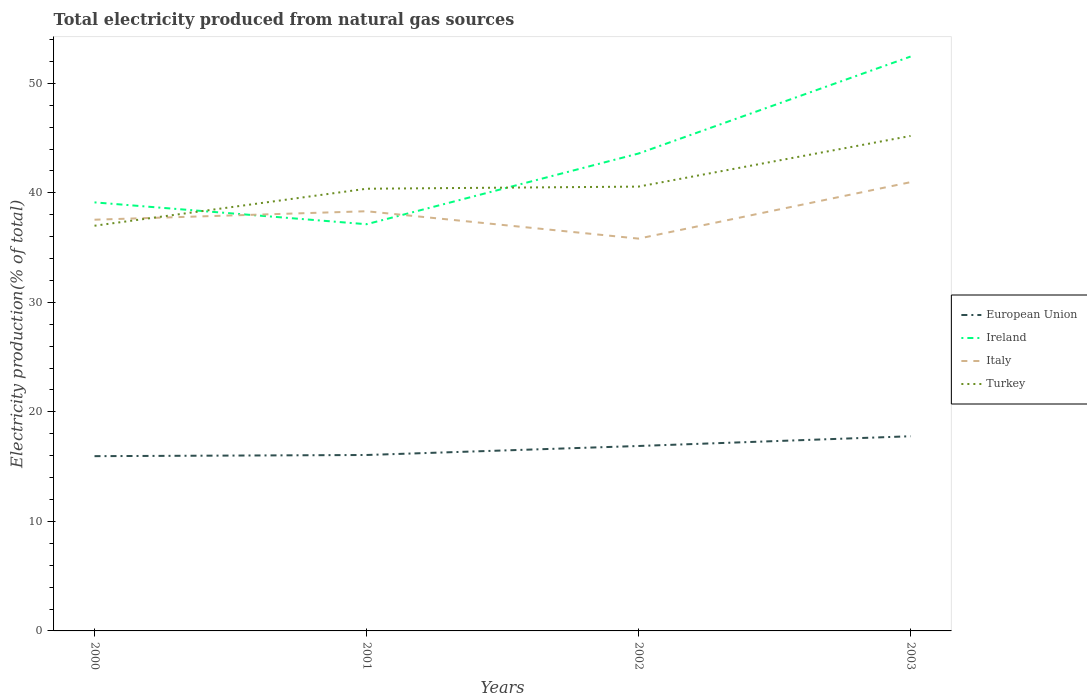How many different coloured lines are there?
Provide a short and direct response. 4. Across all years, what is the maximum total electricity produced in Ireland?
Provide a short and direct response. 37.13. What is the total total electricity produced in European Union in the graph?
Make the answer very short. -0.11. What is the difference between the highest and the second highest total electricity produced in Ireland?
Your answer should be very brief. 15.31. What is the difference between the highest and the lowest total electricity produced in Ireland?
Give a very brief answer. 2. Is the total electricity produced in European Union strictly greater than the total electricity produced in Ireland over the years?
Provide a short and direct response. Yes. What is the difference between two consecutive major ticks on the Y-axis?
Offer a terse response. 10. Does the graph contain any zero values?
Your answer should be very brief. No. How many legend labels are there?
Your answer should be compact. 4. What is the title of the graph?
Provide a succinct answer. Total electricity produced from natural gas sources. What is the label or title of the X-axis?
Your response must be concise. Years. What is the Electricity production(% of total) in European Union in 2000?
Your response must be concise. 15.96. What is the Electricity production(% of total) in Ireland in 2000?
Keep it short and to the point. 39.13. What is the Electricity production(% of total) in Italy in 2000?
Ensure brevity in your answer.  37.55. What is the Electricity production(% of total) in Turkey in 2000?
Your answer should be very brief. 37. What is the Electricity production(% of total) in European Union in 2001?
Keep it short and to the point. 16.06. What is the Electricity production(% of total) in Ireland in 2001?
Keep it short and to the point. 37.13. What is the Electricity production(% of total) in Italy in 2001?
Make the answer very short. 38.32. What is the Electricity production(% of total) of Turkey in 2001?
Ensure brevity in your answer.  40.37. What is the Electricity production(% of total) in European Union in 2002?
Offer a very short reply. 16.89. What is the Electricity production(% of total) of Ireland in 2002?
Offer a very short reply. 43.59. What is the Electricity production(% of total) in Italy in 2002?
Your answer should be very brief. 35.82. What is the Electricity production(% of total) of Turkey in 2002?
Your answer should be compact. 40.57. What is the Electricity production(% of total) of European Union in 2003?
Your answer should be very brief. 17.78. What is the Electricity production(% of total) of Ireland in 2003?
Your answer should be very brief. 52.44. What is the Electricity production(% of total) in Italy in 2003?
Provide a short and direct response. 40.97. What is the Electricity production(% of total) in Turkey in 2003?
Ensure brevity in your answer.  45.2. Across all years, what is the maximum Electricity production(% of total) in European Union?
Give a very brief answer. 17.78. Across all years, what is the maximum Electricity production(% of total) in Ireland?
Offer a terse response. 52.44. Across all years, what is the maximum Electricity production(% of total) of Italy?
Your response must be concise. 40.97. Across all years, what is the maximum Electricity production(% of total) in Turkey?
Provide a succinct answer. 45.2. Across all years, what is the minimum Electricity production(% of total) in European Union?
Keep it short and to the point. 15.96. Across all years, what is the minimum Electricity production(% of total) of Ireland?
Provide a short and direct response. 37.13. Across all years, what is the minimum Electricity production(% of total) in Italy?
Offer a very short reply. 35.82. Across all years, what is the minimum Electricity production(% of total) in Turkey?
Your answer should be very brief. 37. What is the total Electricity production(% of total) of European Union in the graph?
Your answer should be compact. 66.68. What is the total Electricity production(% of total) in Ireland in the graph?
Offer a very short reply. 172.3. What is the total Electricity production(% of total) of Italy in the graph?
Offer a very short reply. 152.66. What is the total Electricity production(% of total) in Turkey in the graph?
Offer a very short reply. 163.14. What is the difference between the Electricity production(% of total) in European Union in 2000 and that in 2001?
Offer a very short reply. -0.11. What is the difference between the Electricity production(% of total) in Ireland in 2000 and that in 2001?
Give a very brief answer. 1.99. What is the difference between the Electricity production(% of total) in Italy in 2000 and that in 2001?
Keep it short and to the point. -0.77. What is the difference between the Electricity production(% of total) of Turkey in 2000 and that in 2001?
Give a very brief answer. -3.38. What is the difference between the Electricity production(% of total) in European Union in 2000 and that in 2002?
Ensure brevity in your answer.  -0.93. What is the difference between the Electricity production(% of total) of Ireland in 2000 and that in 2002?
Provide a short and direct response. -4.46. What is the difference between the Electricity production(% of total) in Italy in 2000 and that in 2002?
Keep it short and to the point. 1.73. What is the difference between the Electricity production(% of total) in Turkey in 2000 and that in 2002?
Keep it short and to the point. -3.57. What is the difference between the Electricity production(% of total) in European Union in 2000 and that in 2003?
Provide a short and direct response. -1.82. What is the difference between the Electricity production(% of total) of Ireland in 2000 and that in 2003?
Your answer should be compact. -13.31. What is the difference between the Electricity production(% of total) in Italy in 2000 and that in 2003?
Your answer should be compact. -3.43. What is the difference between the Electricity production(% of total) of Turkey in 2000 and that in 2003?
Provide a succinct answer. -8.2. What is the difference between the Electricity production(% of total) in European Union in 2001 and that in 2002?
Provide a succinct answer. -0.82. What is the difference between the Electricity production(% of total) in Ireland in 2001 and that in 2002?
Your answer should be very brief. -6.46. What is the difference between the Electricity production(% of total) in Italy in 2001 and that in 2002?
Give a very brief answer. 2.5. What is the difference between the Electricity production(% of total) in Turkey in 2001 and that in 2002?
Keep it short and to the point. -0.19. What is the difference between the Electricity production(% of total) of European Union in 2001 and that in 2003?
Ensure brevity in your answer.  -1.71. What is the difference between the Electricity production(% of total) of Ireland in 2001 and that in 2003?
Give a very brief answer. -15.31. What is the difference between the Electricity production(% of total) in Italy in 2001 and that in 2003?
Provide a short and direct response. -2.65. What is the difference between the Electricity production(% of total) of Turkey in 2001 and that in 2003?
Your answer should be very brief. -4.82. What is the difference between the Electricity production(% of total) of European Union in 2002 and that in 2003?
Your answer should be compact. -0.89. What is the difference between the Electricity production(% of total) of Ireland in 2002 and that in 2003?
Provide a succinct answer. -8.85. What is the difference between the Electricity production(% of total) of Italy in 2002 and that in 2003?
Your response must be concise. -5.15. What is the difference between the Electricity production(% of total) in Turkey in 2002 and that in 2003?
Offer a very short reply. -4.63. What is the difference between the Electricity production(% of total) in European Union in 2000 and the Electricity production(% of total) in Ireland in 2001?
Your answer should be compact. -21.18. What is the difference between the Electricity production(% of total) of European Union in 2000 and the Electricity production(% of total) of Italy in 2001?
Make the answer very short. -22.36. What is the difference between the Electricity production(% of total) in European Union in 2000 and the Electricity production(% of total) in Turkey in 2001?
Give a very brief answer. -24.42. What is the difference between the Electricity production(% of total) of Ireland in 2000 and the Electricity production(% of total) of Italy in 2001?
Make the answer very short. 0.81. What is the difference between the Electricity production(% of total) of Ireland in 2000 and the Electricity production(% of total) of Turkey in 2001?
Your answer should be very brief. -1.25. What is the difference between the Electricity production(% of total) of Italy in 2000 and the Electricity production(% of total) of Turkey in 2001?
Your answer should be compact. -2.83. What is the difference between the Electricity production(% of total) of European Union in 2000 and the Electricity production(% of total) of Ireland in 2002?
Offer a terse response. -27.63. What is the difference between the Electricity production(% of total) of European Union in 2000 and the Electricity production(% of total) of Italy in 2002?
Offer a very short reply. -19.86. What is the difference between the Electricity production(% of total) of European Union in 2000 and the Electricity production(% of total) of Turkey in 2002?
Provide a short and direct response. -24.61. What is the difference between the Electricity production(% of total) of Ireland in 2000 and the Electricity production(% of total) of Italy in 2002?
Keep it short and to the point. 3.31. What is the difference between the Electricity production(% of total) in Ireland in 2000 and the Electricity production(% of total) in Turkey in 2002?
Provide a short and direct response. -1.44. What is the difference between the Electricity production(% of total) in Italy in 2000 and the Electricity production(% of total) in Turkey in 2002?
Provide a succinct answer. -3.02. What is the difference between the Electricity production(% of total) in European Union in 2000 and the Electricity production(% of total) in Ireland in 2003?
Offer a terse response. -36.49. What is the difference between the Electricity production(% of total) in European Union in 2000 and the Electricity production(% of total) in Italy in 2003?
Offer a very short reply. -25.02. What is the difference between the Electricity production(% of total) in European Union in 2000 and the Electricity production(% of total) in Turkey in 2003?
Give a very brief answer. -29.24. What is the difference between the Electricity production(% of total) in Ireland in 2000 and the Electricity production(% of total) in Italy in 2003?
Provide a succinct answer. -1.85. What is the difference between the Electricity production(% of total) in Ireland in 2000 and the Electricity production(% of total) in Turkey in 2003?
Your response must be concise. -6.07. What is the difference between the Electricity production(% of total) of Italy in 2000 and the Electricity production(% of total) of Turkey in 2003?
Make the answer very short. -7.65. What is the difference between the Electricity production(% of total) in European Union in 2001 and the Electricity production(% of total) in Ireland in 2002?
Offer a very short reply. -27.53. What is the difference between the Electricity production(% of total) of European Union in 2001 and the Electricity production(% of total) of Italy in 2002?
Make the answer very short. -19.76. What is the difference between the Electricity production(% of total) of European Union in 2001 and the Electricity production(% of total) of Turkey in 2002?
Offer a very short reply. -24.51. What is the difference between the Electricity production(% of total) in Ireland in 2001 and the Electricity production(% of total) in Italy in 2002?
Make the answer very short. 1.31. What is the difference between the Electricity production(% of total) of Ireland in 2001 and the Electricity production(% of total) of Turkey in 2002?
Your answer should be very brief. -3.43. What is the difference between the Electricity production(% of total) in Italy in 2001 and the Electricity production(% of total) in Turkey in 2002?
Make the answer very short. -2.25. What is the difference between the Electricity production(% of total) of European Union in 2001 and the Electricity production(% of total) of Ireland in 2003?
Your response must be concise. -36.38. What is the difference between the Electricity production(% of total) of European Union in 2001 and the Electricity production(% of total) of Italy in 2003?
Offer a very short reply. -24.91. What is the difference between the Electricity production(% of total) of European Union in 2001 and the Electricity production(% of total) of Turkey in 2003?
Give a very brief answer. -29.13. What is the difference between the Electricity production(% of total) of Ireland in 2001 and the Electricity production(% of total) of Italy in 2003?
Give a very brief answer. -3.84. What is the difference between the Electricity production(% of total) of Ireland in 2001 and the Electricity production(% of total) of Turkey in 2003?
Offer a terse response. -8.06. What is the difference between the Electricity production(% of total) in Italy in 2001 and the Electricity production(% of total) in Turkey in 2003?
Provide a short and direct response. -6.88. What is the difference between the Electricity production(% of total) in European Union in 2002 and the Electricity production(% of total) in Ireland in 2003?
Your response must be concise. -35.56. What is the difference between the Electricity production(% of total) in European Union in 2002 and the Electricity production(% of total) in Italy in 2003?
Your answer should be compact. -24.09. What is the difference between the Electricity production(% of total) in European Union in 2002 and the Electricity production(% of total) in Turkey in 2003?
Your answer should be very brief. -28.31. What is the difference between the Electricity production(% of total) in Ireland in 2002 and the Electricity production(% of total) in Italy in 2003?
Your answer should be very brief. 2.62. What is the difference between the Electricity production(% of total) in Ireland in 2002 and the Electricity production(% of total) in Turkey in 2003?
Give a very brief answer. -1.61. What is the difference between the Electricity production(% of total) of Italy in 2002 and the Electricity production(% of total) of Turkey in 2003?
Provide a short and direct response. -9.37. What is the average Electricity production(% of total) of European Union per year?
Offer a very short reply. 16.67. What is the average Electricity production(% of total) of Ireland per year?
Your response must be concise. 43.07. What is the average Electricity production(% of total) of Italy per year?
Make the answer very short. 38.17. What is the average Electricity production(% of total) in Turkey per year?
Your answer should be very brief. 40.78. In the year 2000, what is the difference between the Electricity production(% of total) in European Union and Electricity production(% of total) in Ireland?
Provide a succinct answer. -23.17. In the year 2000, what is the difference between the Electricity production(% of total) in European Union and Electricity production(% of total) in Italy?
Make the answer very short. -21.59. In the year 2000, what is the difference between the Electricity production(% of total) in European Union and Electricity production(% of total) in Turkey?
Your answer should be compact. -21.04. In the year 2000, what is the difference between the Electricity production(% of total) of Ireland and Electricity production(% of total) of Italy?
Provide a short and direct response. 1.58. In the year 2000, what is the difference between the Electricity production(% of total) in Ireland and Electricity production(% of total) in Turkey?
Your response must be concise. 2.13. In the year 2000, what is the difference between the Electricity production(% of total) of Italy and Electricity production(% of total) of Turkey?
Your answer should be very brief. 0.55. In the year 2001, what is the difference between the Electricity production(% of total) in European Union and Electricity production(% of total) in Ireland?
Provide a short and direct response. -21.07. In the year 2001, what is the difference between the Electricity production(% of total) in European Union and Electricity production(% of total) in Italy?
Give a very brief answer. -22.26. In the year 2001, what is the difference between the Electricity production(% of total) in European Union and Electricity production(% of total) in Turkey?
Your response must be concise. -24.31. In the year 2001, what is the difference between the Electricity production(% of total) of Ireland and Electricity production(% of total) of Italy?
Keep it short and to the point. -1.18. In the year 2001, what is the difference between the Electricity production(% of total) of Ireland and Electricity production(% of total) of Turkey?
Give a very brief answer. -3.24. In the year 2001, what is the difference between the Electricity production(% of total) of Italy and Electricity production(% of total) of Turkey?
Your answer should be very brief. -2.06. In the year 2002, what is the difference between the Electricity production(% of total) of European Union and Electricity production(% of total) of Ireland?
Your answer should be very brief. -26.7. In the year 2002, what is the difference between the Electricity production(% of total) in European Union and Electricity production(% of total) in Italy?
Your answer should be very brief. -18.93. In the year 2002, what is the difference between the Electricity production(% of total) of European Union and Electricity production(% of total) of Turkey?
Keep it short and to the point. -23.68. In the year 2002, what is the difference between the Electricity production(% of total) of Ireland and Electricity production(% of total) of Italy?
Offer a very short reply. 7.77. In the year 2002, what is the difference between the Electricity production(% of total) in Ireland and Electricity production(% of total) in Turkey?
Make the answer very short. 3.02. In the year 2002, what is the difference between the Electricity production(% of total) in Italy and Electricity production(% of total) in Turkey?
Offer a terse response. -4.75. In the year 2003, what is the difference between the Electricity production(% of total) of European Union and Electricity production(% of total) of Ireland?
Provide a short and direct response. -34.67. In the year 2003, what is the difference between the Electricity production(% of total) of European Union and Electricity production(% of total) of Italy?
Your answer should be compact. -23.2. In the year 2003, what is the difference between the Electricity production(% of total) in European Union and Electricity production(% of total) in Turkey?
Make the answer very short. -27.42. In the year 2003, what is the difference between the Electricity production(% of total) in Ireland and Electricity production(% of total) in Italy?
Keep it short and to the point. 11.47. In the year 2003, what is the difference between the Electricity production(% of total) of Ireland and Electricity production(% of total) of Turkey?
Offer a terse response. 7.25. In the year 2003, what is the difference between the Electricity production(% of total) in Italy and Electricity production(% of total) in Turkey?
Provide a succinct answer. -4.22. What is the ratio of the Electricity production(% of total) in European Union in 2000 to that in 2001?
Make the answer very short. 0.99. What is the ratio of the Electricity production(% of total) of Ireland in 2000 to that in 2001?
Give a very brief answer. 1.05. What is the ratio of the Electricity production(% of total) in Italy in 2000 to that in 2001?
Offer a very short reply. 0.98. What is the ratio of the Electricity production(% of total) of Turkey in 2000 to that in 2001?
Make the answer very short. 0.92. What is the ratio of the Electricity production(% of total) of European Union in 2000 to that in 2002?
Keep it short and to the point. 0.94. What is the ratio of the Electricity production(% of total) in Ireland in 2000 to that in 2002?
Keep it short and to the point. 0.9. What is the ratio of the Electricity production(% of total) of Italy in 2000 to that in 2002?
Offer a very short reply. 1.05. What is the ratio of the Electricity production(% of total) in Turkey in 2000 to that in 2002?
Provide a short and direct response. 0.91. What is the ratio of the Electricity production(% of total) of European Union in 2000 to that in 2003?
Your answer should be compact. 0.9. What is the ratio of the Electricity production(% of total) in Ireland in 2000 to that in 2003?
Give a very brief answer. 0.75. What is the ratio of the Electricity production(% of total) of Italy in 2000 to that in 2003?
Make the answer very short. 0.92. What is the ratio of the Electricity production(% of total) in Turkey in 2000 to that in 2003?
Provide a short and direct response. 0.82. What is the ratio of the Electricity production(% of total) in European Union in 2001 to that in 2002?
Provide a succinct answer. 0.95. What is the ratio of the Electricity production(% of total) in Ireland in 2001 to that in 2002?
Provide a succinct answer. 0.85. What is the ratio of the Electricity production(% of total) in Italy in 2001 to that in 2002?
Your answer should be very brief. 1.07. What is the ratio of the Electricity production(% of total) in Turkey in 2001 to that in 2002?
Provide a short and direct response. 1. What is the ratio of the Electricity production(% of total) in European Union in 2001 to that in 2003?
Offer a terse response. 0.9. What is the ratio of the Electricity production(% of total) in Ireland in 2001 to that in 2003?
Your answer should be very brief. 0.71. What is the ratio of the Electricity production(% of total) of Italy in 2001 to that in 2003?
Offer a terse response. 0.94. What is the ratio of the Electricity production(% of total) in Turkey in 2001 to that in 2003?
Your response must be concise. 0.89. What is the ratio of the Electricity production(% of total) of European Union in 2002 to that in 2003?
Provide a short and direct response. 0.95. What is the ratio of the Electricity production(% of total) in Ireland in 2002 to that in 2003?
Your answer should be compact. 0.83. What is the ratio of the Electricity production(% of total) in Italy in 2002 to that in 2003?
Offer a very short reply. 0.87. What is the ratio of the Electricity production(% of total) of Turkey in 2002 to that in 2003?
Your answer should be compact. 0.9. What is the difference between the highest and the second highest Electricity production(% of total) in European Union?
Keep it short and to the point. 0.89. What is the difference between the highest and the second highest Electricity production(% of total) of Ireland?
Offer a terse response. 8.85. What is the difference between the highest and the second highest Electricity production(% of total) in Italy?
Keep it short and to the point. 2.65. What is the difference between the highest and the second highest Electricity production(% of total) in Turkey?
Provide a succinct answer. 4.63. What is the difference between the highest and the lowest Electricity production(% of total) in European Union?
Provide a succinct answer. 1.82. What is the difference between the highest and the lowest Electricity production(% of total) in Ireland?
Provide a succinct answer. 15.31. What is the difference between the highest and the lowest Electricity production(% of total) of Italy?
Make the answer very short. 5.15. What is the difference between the highest and the lowest Electricity production(% of total) of Turkey?
Your answer should be very brief. 8.2. 